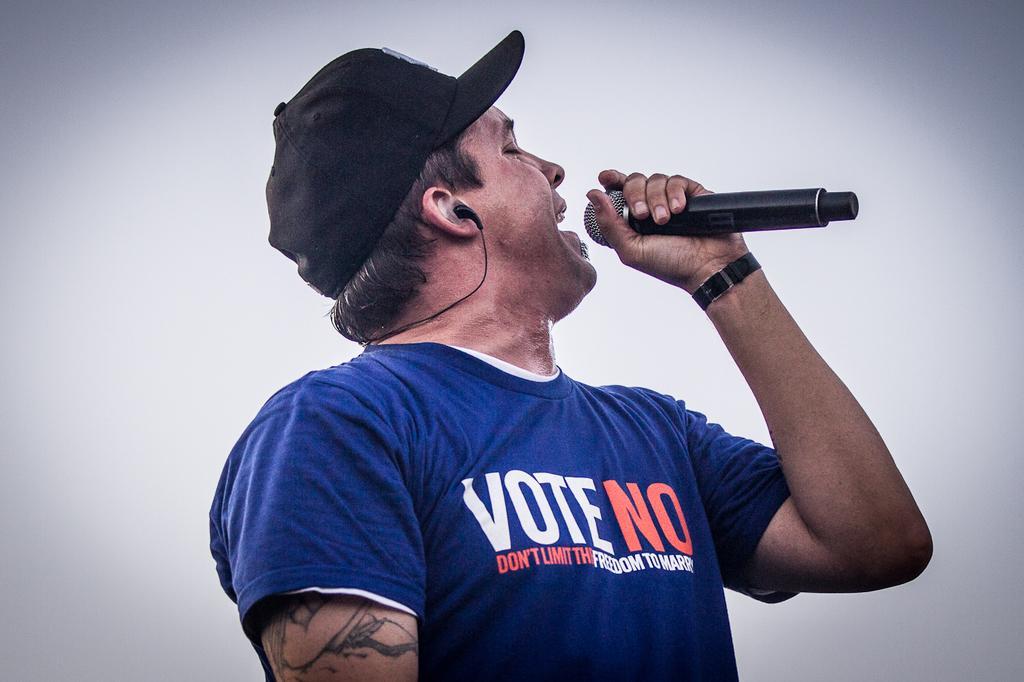How would you summarize this image in a sentence or two? In this image in the middle, there is a man, he wears a t shirt, cap, he is holding a mic, he is singing. The background is white. 